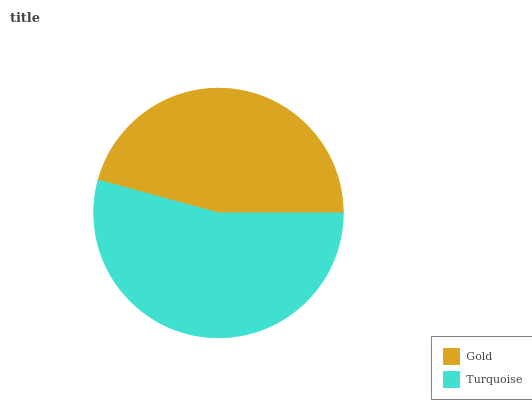Is Gold the minimum?
Answer yes or no. Yes. Is Turquoise the maximum?
Answer yes or no. Yes. Is Turquoise the minimum?
Answer yes or no. No. Is Turquoise greater than Gold?
Answer yes or no. Yes. Is Gold less than Turquoise?
Answer yes or no. Yes. Is Gold greater than Turquoise?
Answer yes or no. No. Is Turquoise less than Gold?
Answer yes or no. No. Is Turquoise the high median?
Answer yes or no. Yes. Is Gold the low median?
Answer yes or no. Yes. Is Gold the high median?
Answer yes or no. No. Is Turquoise the low median?
Answer yes or no. No. 